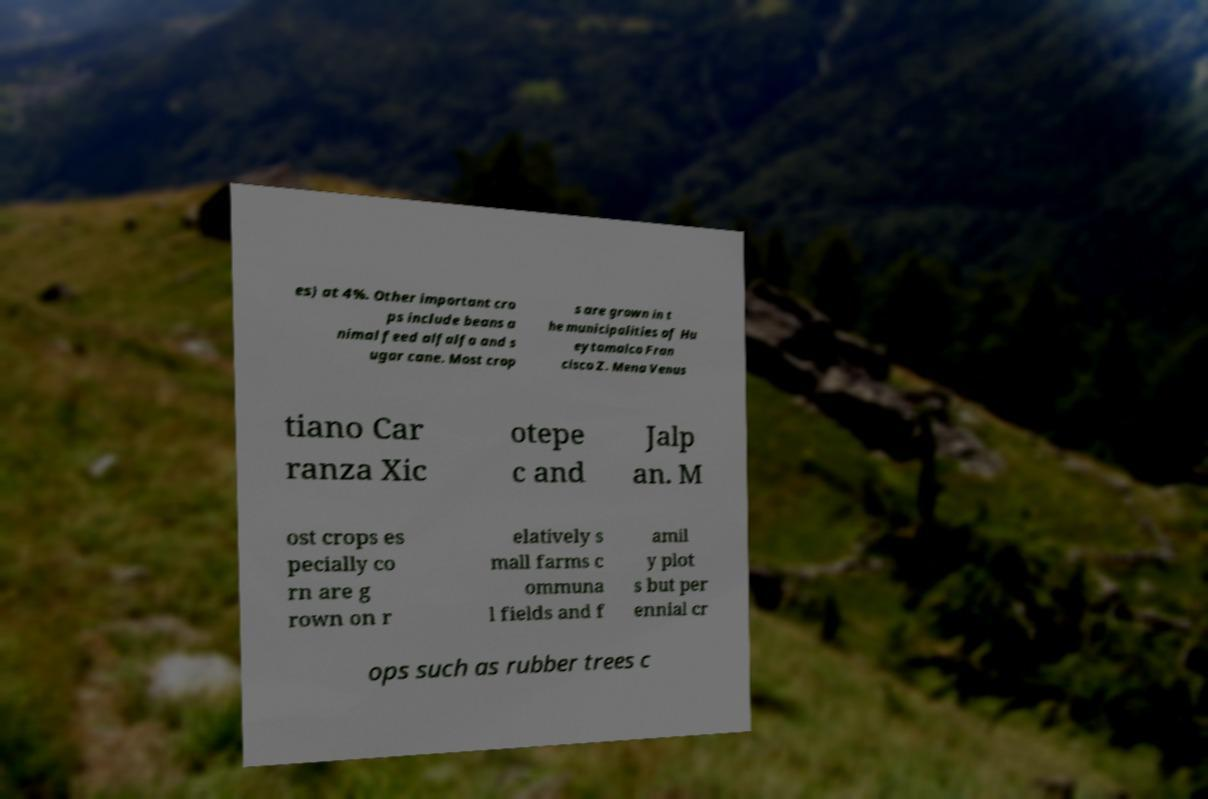Could you assist in decoding the text presented in this image and type it out clearly? es) at 4%. Other important cro ps include beans a nimal feed alfalfa and s ugar cane. Most crop s are grown in t he municipalities of Hu eytamalco Fran cisco Z. Mena Venus tiano Car ranza Xic otepe c and Jalp an. M ost crops es pecially co rn are g rown on r elatively s mall farms c ommuna l fields and f amil y plot s but per ennial cr ops such as rubber trees c 